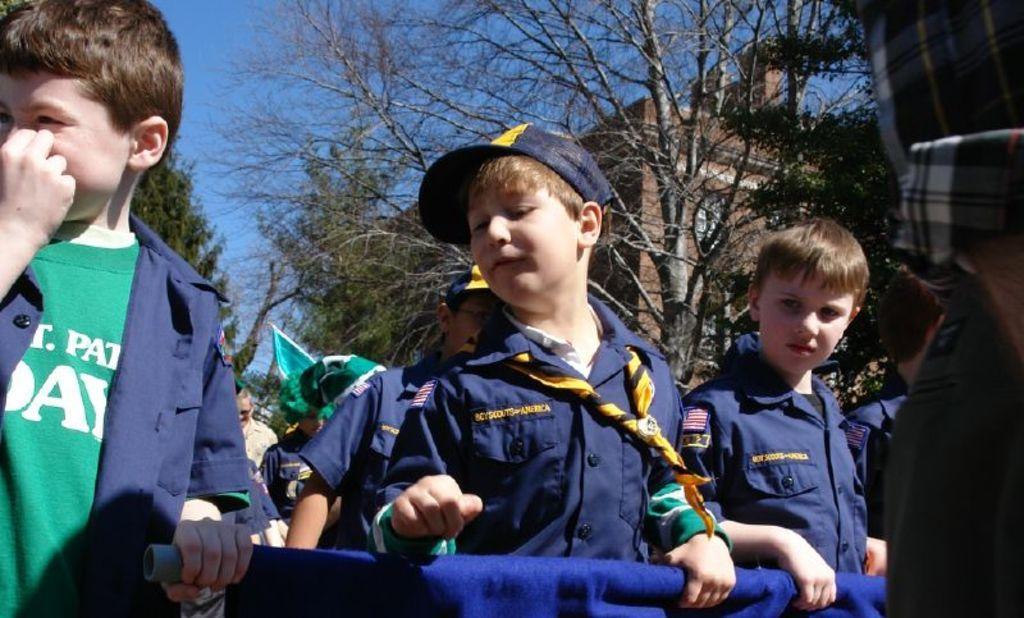In one or two sentences, can you explain what this image depicts? In this image there are children's standing on a road and holding a banner, in the background there are trees, buildings and the sky. 